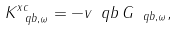Convert formula to latex. <formula><loc_0><loc_0><loc_500><loc_500>K ^ { x c } _ { \ q b , \omega } = - v _ { \ } q b \, G _ { \ q b , \omega } ,</formula> 